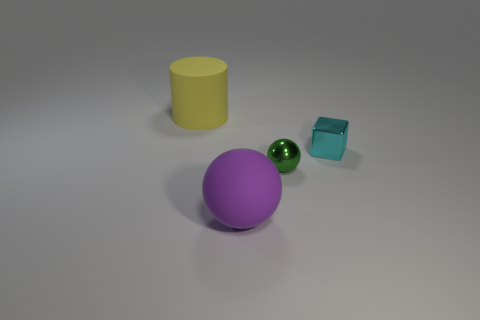What number of objects are behind the tiny shiny cube and to the right of the tiny green metal sphere?
Offer a very short reply. 0. What number of other things are the same size as the cyan metallic object?
Your answer should be very brief. 1. Are there the same number of large balls that are behind the large purple thing and brown shiny blocks?
Ensure brevity in your answer.  Yes. Do the tiny metallic object right of the metallic sphere and the matte object in front of the cyan thing have the same color?
Offer a very short reply. No. What is the thing that is both in front of the large yellow thing and behind the tiny ball made of?
Your response must be concise. Metal. The tiny metallic sphere has what color?
Offer a very short reply. Green. What number of other objects are the same shape as the big purple thing?
Provide a short and direct response. 1. Are there the same number of big balls that are in front of the large rubber ball and green things that are right of the cyan cube?
Your response must be concise. Yes. What is the big yellow cylinder made of?
Give a very brief answer. Rubber. What material is the tiny cyan object in front of the cylinder?
Provide a succinct answer. Metal. 